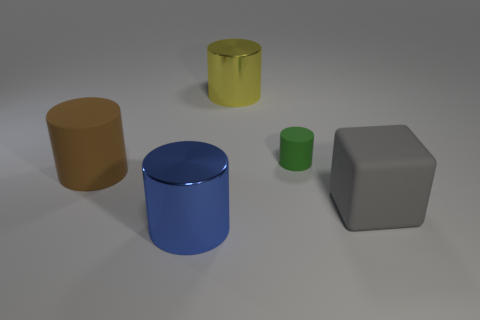Subtract all brown matte cylinders. How many cylinders are left? 3 Add 1 green shiny blocks. How many objects exist? 6 Subtract all yellow cylinders. How many cylinders are left? 3 Subtract all cubes. How many objects are left? 4 Add 1 brown rubber objects. How many brown rubber objects exist? 2 Subtract 0 cyan spheres. How many objects are left? 5 Subtract 4 cylinders. How many cylinders are left? 0 Subtract all gray cylinders. Subtract all cyan spheres. How many cylinders are left? 4 Subtract all small cyan rubber cylinders. Subtract all cylinders. How many objects are left? 1 Add 1 big blue things. How many big blue things are left? 2 